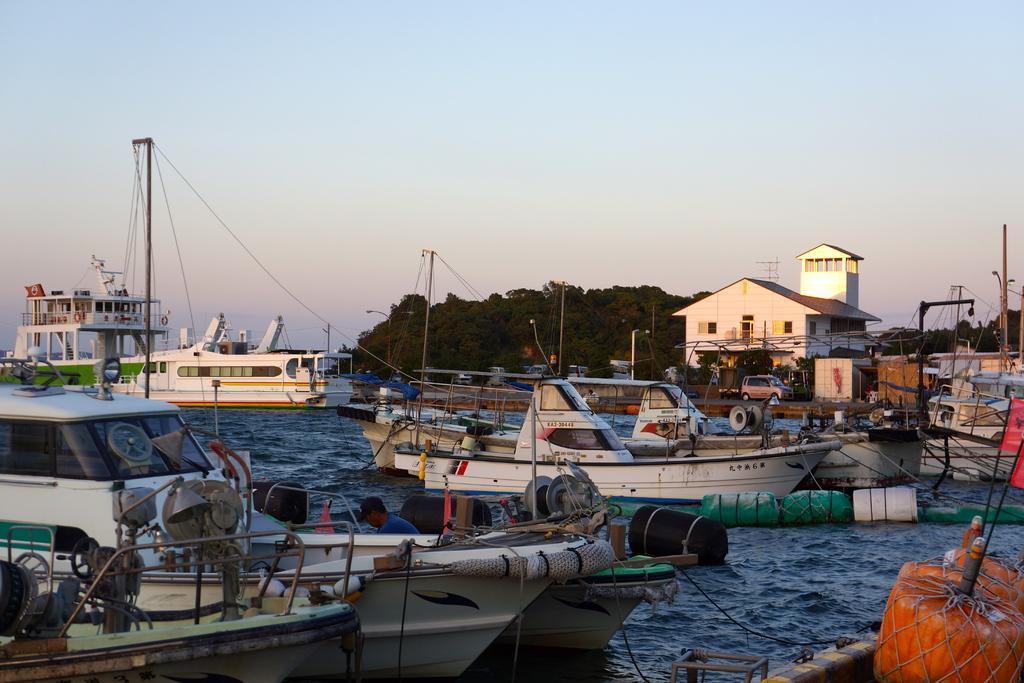In one or two sentences, can you explain what this image depicts? The picture is taken near a shipping harbor. In the foreground of the picture there are boats. In the center of the picture there are trees, vehicles and buildings. 